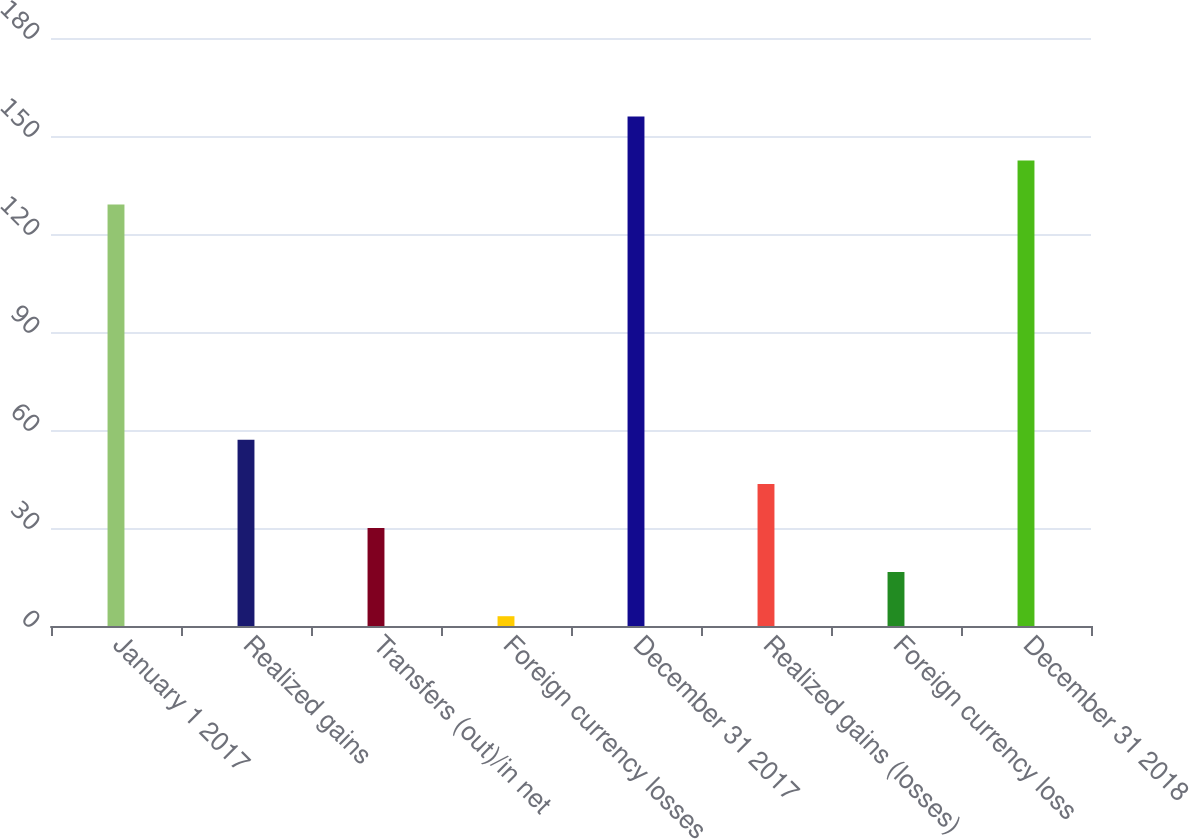Convert chart to OTSL. <chart><loc_0><loc_0><loc_500><loc_500><bar_chart><fcel>January 1 2017<fcel>Realized gains<fcel>Transfers (out)/in net<fcel>Foreign currency losses<fcel>December 31 2017<fcel>Realized gains (losses)<fcel>Foreign currency loss<fcel>December 31 2018<nl><fcel>129<fcel>57<fcel>30<fcel>3<fcel>156<fcel>43.5<fcel>16.5<fcel>142.5<nl></chart> 